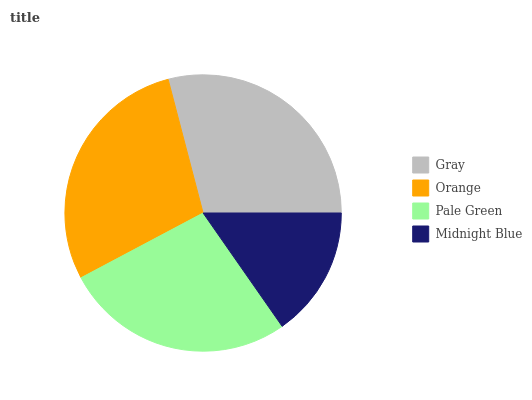Is Midnight Blue the minimum?
Answer yes or no. Yes. Is Gray the maximum?
Answer yes or no. Yes. Is Orange the minimum?
Answer yes or no. No. Is Orange the maximum?
Answer yes or no. No. Is Gray greater than Orange?
Answer yes or no. Yes. Is Orange less than Gray?
Answer yes or no. Yes. Is Orange greater than Gray?
Answer yes or no. No. Is Gray less than Orange?
Answer yes or no. No. Is Orange the high median?
Answer yes or no. Yes. Is Pale Green the low median?
Answer yes or no. Yes. Is Gray the high median?
Answer yes or no. No. Is Midnight Blue the low median?
Answer yes or no. No. 